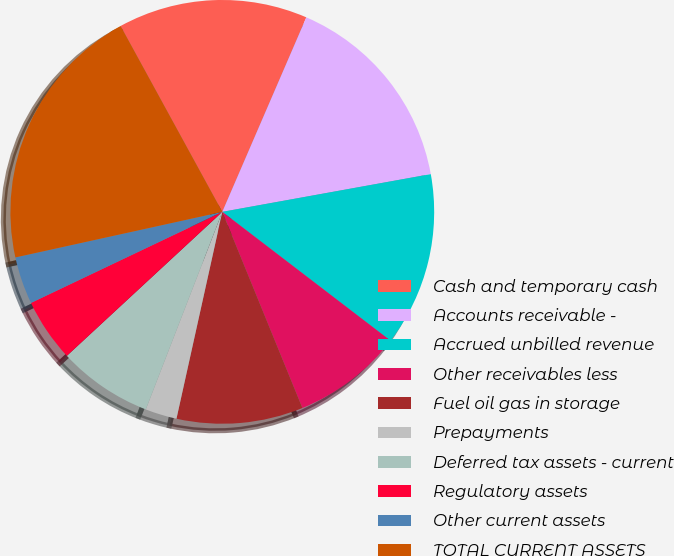Convert chart. <chart><loc_0><loc_0><loc_500><loc_500><pie_chart><fcel>Cash and temporary cash<fcel>Accounts receivable -<fcel>Accrued unbilled revenue<fcel>Other receivables less<fcel>Fuel oil gas in storage<fcel>Prepayments<fcel>Deferred tax assets - current<fcel>Regulatory assets<fcel>Other current assets<fcel>TOTAL CURRENT ASSETS<nl><fcel>14.46%<fcel>15.66%<fcel>13.25%<fcel>8.43%<fcel>9.64%<fcel>2.41%<fcel>7.23%<fcel>4.82%<fcel>3.62%<fcel>20.48%<nl></chart> 